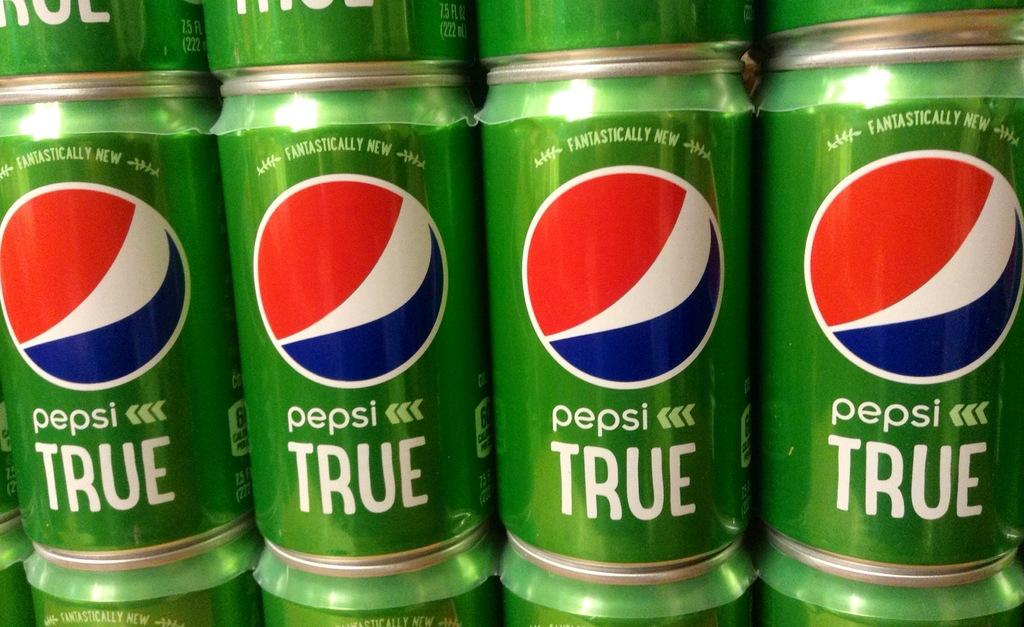What type of product is contained in the cans in the image? The cans in the image contain Pepsi. What is the color of the Pepsi cans in the image? The Pepsi cans in the image are green in color. What type of boot is visible in the image? There is no boot present in the image; it features green color Pepsi cans. What type of range can be seen in the image? There is no range present in the image; it features green color Pepsi cans. 